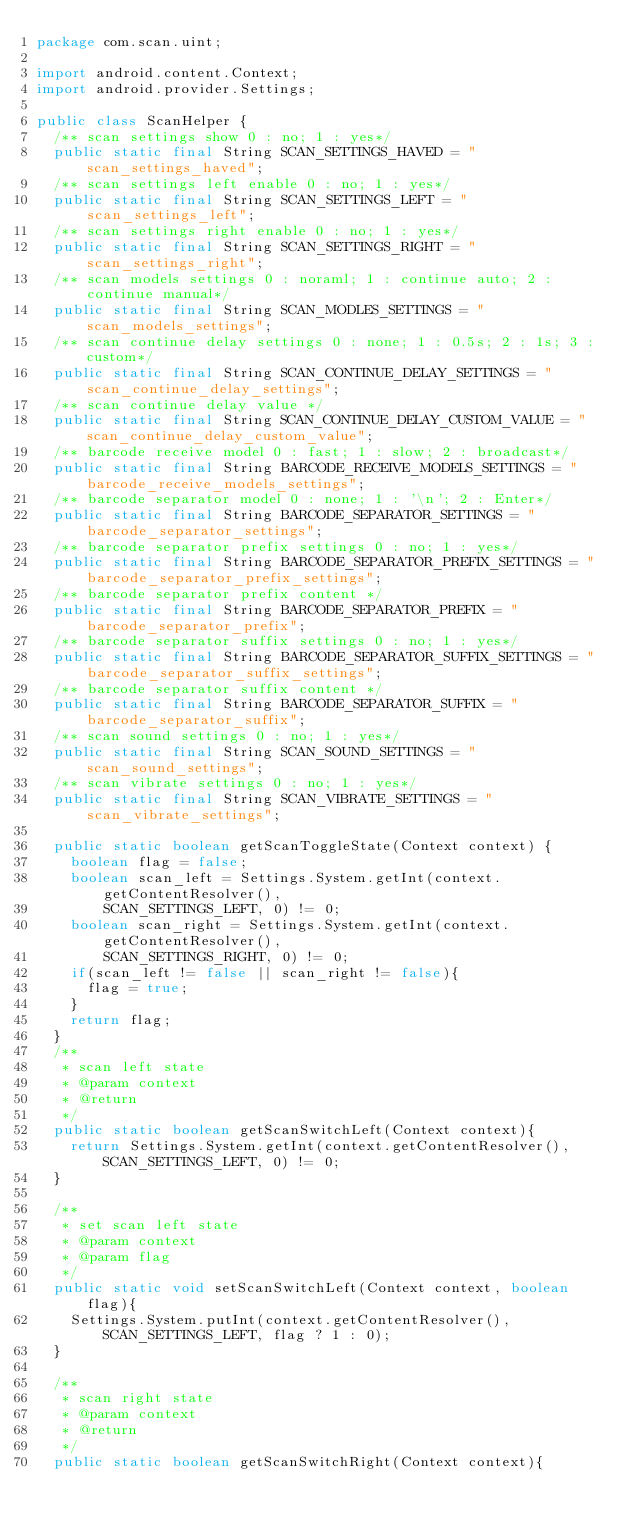Convert code to text. <code><loc_0><loc_0><loc_500><loc_500><_Java_>package com.scan.uint;

import android.content.Context;
import android.provider.Settings;

public class ScanHelper {
	/** scan settings show 0 : no; 1 : yes*/
	public static final String SCAN_SETTINGS_HAVED = "scan_settings_haved";
	/** scan settings left enable 0 : no; 1 : yes*/
	public static final String SCAN_SETTINGS_LEFT = "scan_settings_left";
	/** scan settings right enable 0 : no; 1 : yes*/
	public static final String SCAN_SETTINGS_RIGHT = "scan_settings_right";
	/** scan models settings 0 : noraml; 1 : continue auto; 2 : continue manual*/
	public static final String SCAN_MODLES_SETTINGS = "scan_models_settings";
	/** scan continue delay settings 0 : none; 1 : 0.5s; 2 : 1s; 3 : custom*/
	public static final String SCAN_CONTINUE_DELAY_SETTINGS = "scan_continue_delay_settings";
	/** scan continue delay value */
	public static final String SCAN_CONTINUE_DELAY_CUSTOM_VALUE = "scan_continue_delay_custom_value";
	/** barcode receive model 0 : fast; 1 : slow; 2 : broadcast*/
	public static final String BARCODE_RECEIVE_MODELS_SETTINGS = "barcode_receive_models_settings";
	/** barcode separator model 0 : none; 1 : '\n'; 2 : Enter*/
	public static final String BARCODE_SEPARATOR_SETTINGS = "barcode_separator_settings";
	/** barcode separator prefix settings 0 : no; 1 : yes*/
	public static final String BARCODE_SEPARATOR_PREFIX_SETTINGS = "barcode_separator_prefix_settings";
	/** barcode separator prefix content */
	public static final String BARCODE_SEPARATOR_PREFIX = "barcode_separator_prefix";
	/** barcode separator suffix settings 0 : no; 1 : yes*/
	public static final String BARCODE_SEPARATOR_SUFFIX_SETTINGS = "barcode_separator_suffix_settings";
	/** barcode separator suffix content */
	public static final String BARCODE_SEPARATOR_SUFFIX = "barcode_separator_suffix";
	/** scan sound settings 0 : no; 1 : yes*/
	public static final String SCAN_SOUND_SETTINGS = "scan_sound_settings";
	/** scan vibrate settings 0 : no; 1 : yes*/
	public static final String SCAN_VIBRATE_SETTINGS = "scan_vibrate_settings";
	
	public static boolean getScanToggleState(Context context) {
		boolean flag = false;
		boolean scan_left = Settings.System.getInt(context.getContentResolver(),
				SCAN_SETTINGS_LEFT, 0) != 0;
		boolean scan_right = Settings.System.getInt(context.getContentResolver(),
				SCAN_SETTINGS_RIGHT, 0) != 0;
		if(scan_left != false || scan_right != false){
			flag = true;
		}
		return flag;
	}	
	/**
	 * scan left state 
	 * @param context
	 * @return
	 */
	public static boolean getScanSwitchLeft(Context context){
		return Settings.System.getInt(context.getContentResolver(), SCAN_SETTINGS_LEFT, 0) != 0;
	}
	
	/**
	 * set scan left state
	 * @param context
	 * @param flag
	 */
	public static void setScanSwitchLeft(Context context, boolean flag){
		Settings.System.putInt(context.getContentResolver(), SCAN_SETTINGS_LEFT, flag ? 1 : 0);
	}
	
	/**
	 * scan right state 
	 * @param context
	 * @return
	 */
	public static boolean getScanSwitchRight(Context context){</code> 